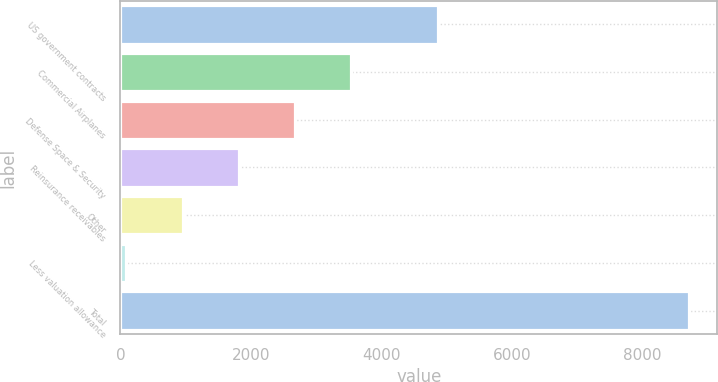<chart> <loc_0><loc_0><loc_500><loc_500><bar_chart><fcel>US government contracts<fcel>Commercial Airplanes<fcel>Defense Space & Security<fcel>Reinsurance receivables<fcel>Other<fcel>Less valuation allowance<fcel>Total<nl><fcel>4864<fcel>3541.6<fcel>2679.7<fcel>1817.8<fcel>955.9<fcel>94<fcel>8713<nl></chart> 